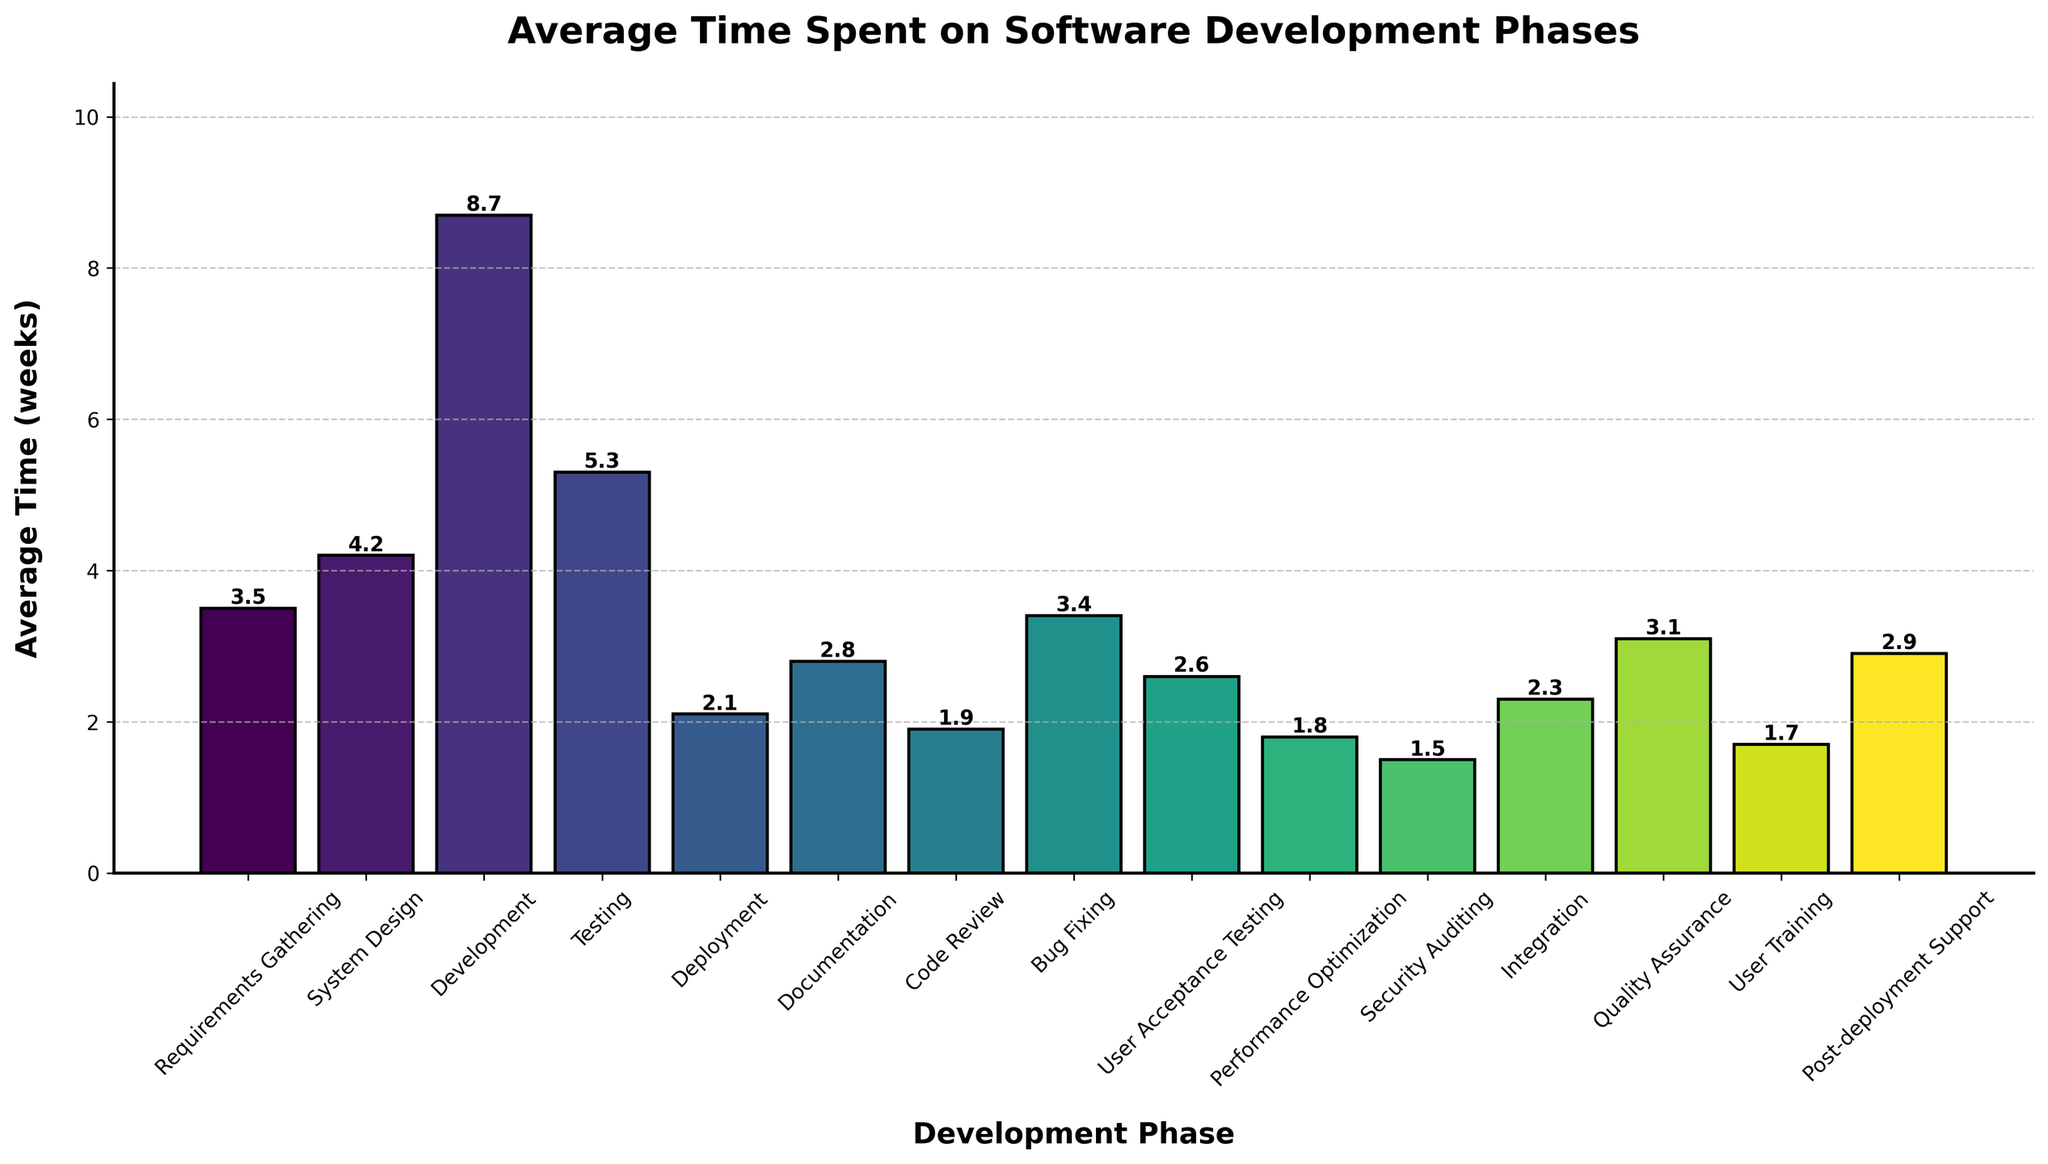Which phase has the longest average time, and what is that time? Look at the heights of the bars to determine which one is the tallest. The tallest bar represents the phase with the longest average time. From the figure, it is Development with an average time of 8.7 weeks.
Answer: Development, 8.7 weeks What is the total average time for Requirements Gathering and Testing phases combined? Find the average times for Requirements Gathering and Testing, which are 3.5 weeks and 5.3 weeks respectively. Add them together: 3.5 + 5.3 = 8.8 weeks.
Answer: 8.8 weeks Which phase takes more time: System Design or User Training? Compare the heights of the bars for System Design and User Training. The System Design bar is higher at 4.2 weeks compared to User Training at 1.7 weeks.
Answer: System Design What is the average time spent on phases whose names start with "User"? Identify the phases: User Acceptance Testing and User Training. Their times are 2.6 and 1.7 weeks respectively. Calculate the average: (2.6 + 1.7) / 2 = 2.15 weeks.
Answer: 2.15 weeks How much longer is the Development phase compared to the Bug Fixing phase? Find the average times for Development and Bug Fixing, which are 8.7 weeks and 3.4 weeks respectively. Subtract Bug Fixing from Development: 8.7 - 3.4 = 5.3 weeks.
Answer: 5.3 weeks Which phases have an average time of less than 2 weeks? Check the bars lower than the 2-week mark. These phases are Code Review (1.9 weeks), Performance Optimization (1.8 weeks), Security Auditing (1.5 weeks), and User Training (1.7 weeks).
Answer: Code Review, Performance Optimization, Security Auditing, User Training If you combine the average times for System Design, Deployment, and Integration, what is the total time? Add the average times for System Design (4.2 weeks), Deployment (2.1 weeks), and Integration (2.3 weeks): 4.2 + 2.1 + 2.3 = 8.6 weeks.
Answer: 8.6 weeks What is the most common range for average time durations among all phases in the figure? Identify the range that contains most of the bars. The majority of the bars fall within the 1.5 to 5.5 weeks range.
Answer: 1.5 to 5.5 weeks Which three phases have the shortest average times? Look for the three shortest bars. They correspond to Security Auditing (1.5 weeks), Performance Optimization (1.8 weeks), and User Training (1.7 weeks).
Answer: Security Auditing, Performance Optimization, User Training 